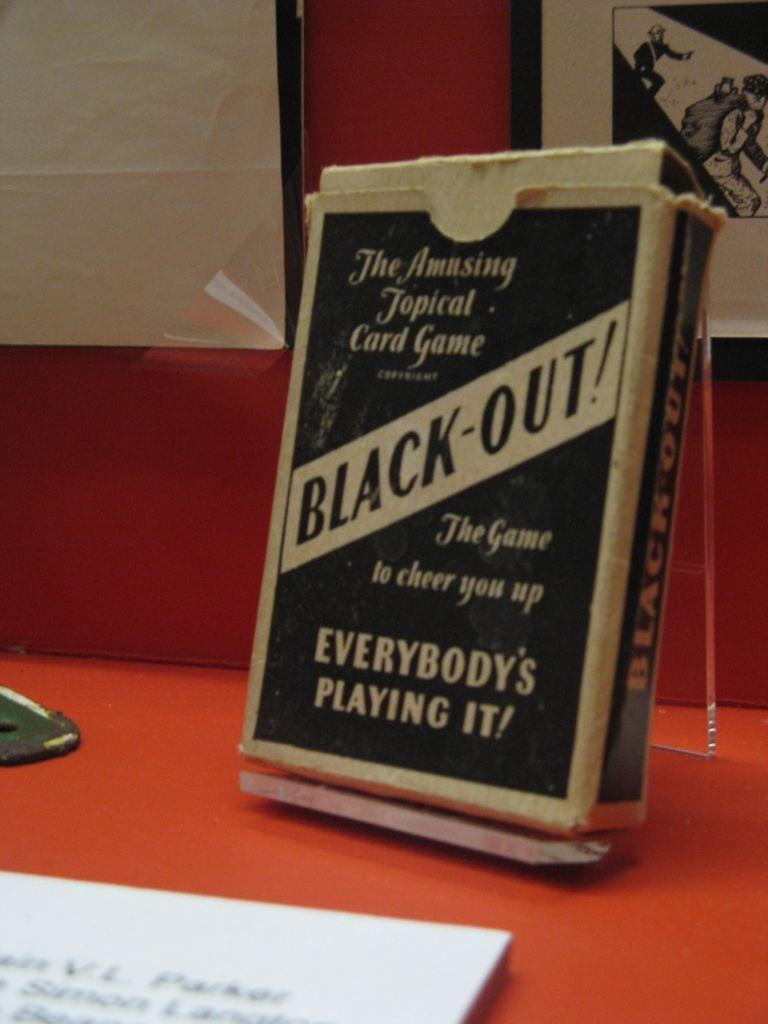Provide a one-sentence caption for the provided image. a book that is called Black Out sits on a table. 